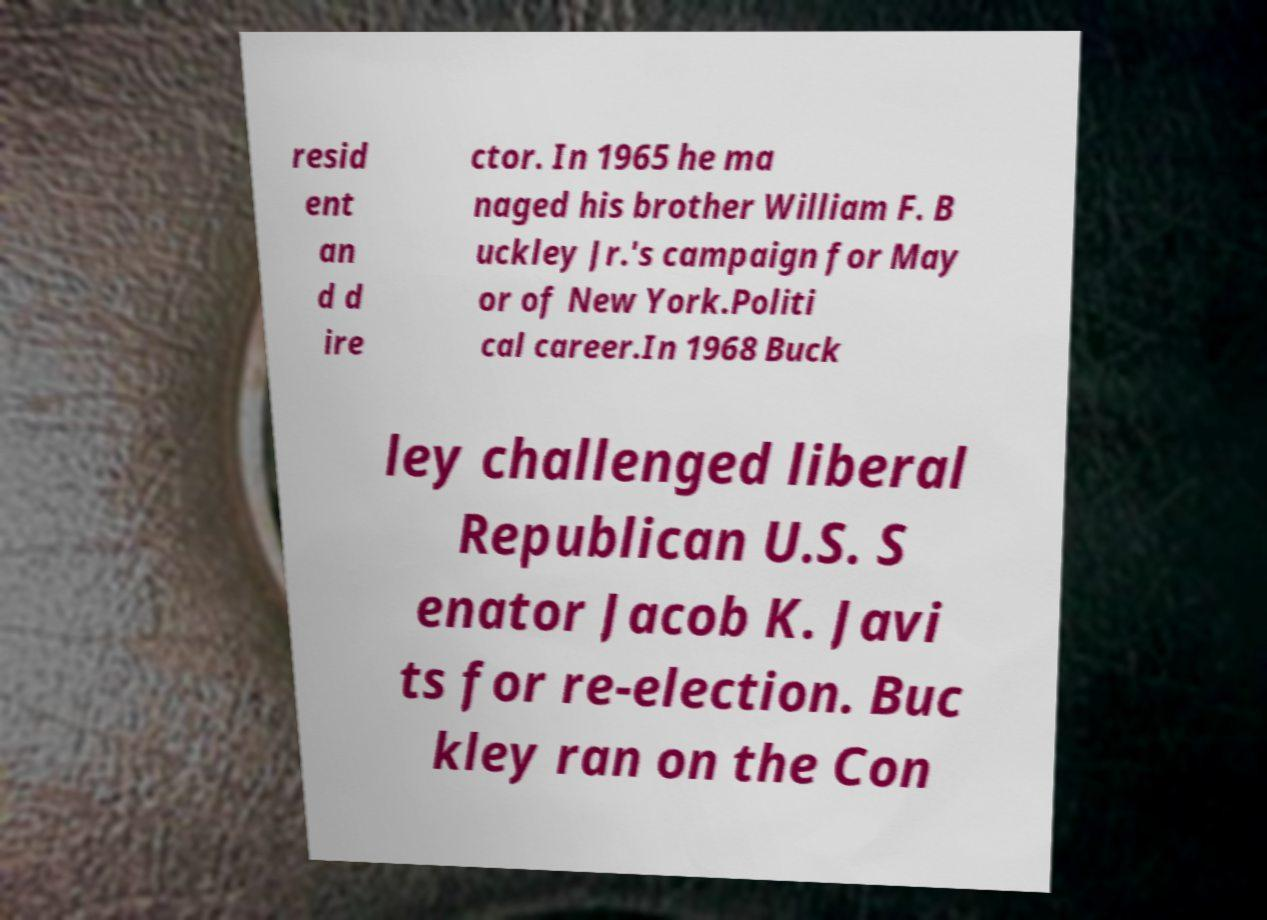Could you assist in decoding the text presented in this image and type it out clearly? resid ent an d d ire ctor. In 1965 he ma naged his brother William F. B uckley Jr.'s campaign for May or of New York.Politi cal career.In 1968 Buck ley challenged liberal Republican U.S. S enator Jacob K. Javi ts for re-election. Buc kley ran on the Con 